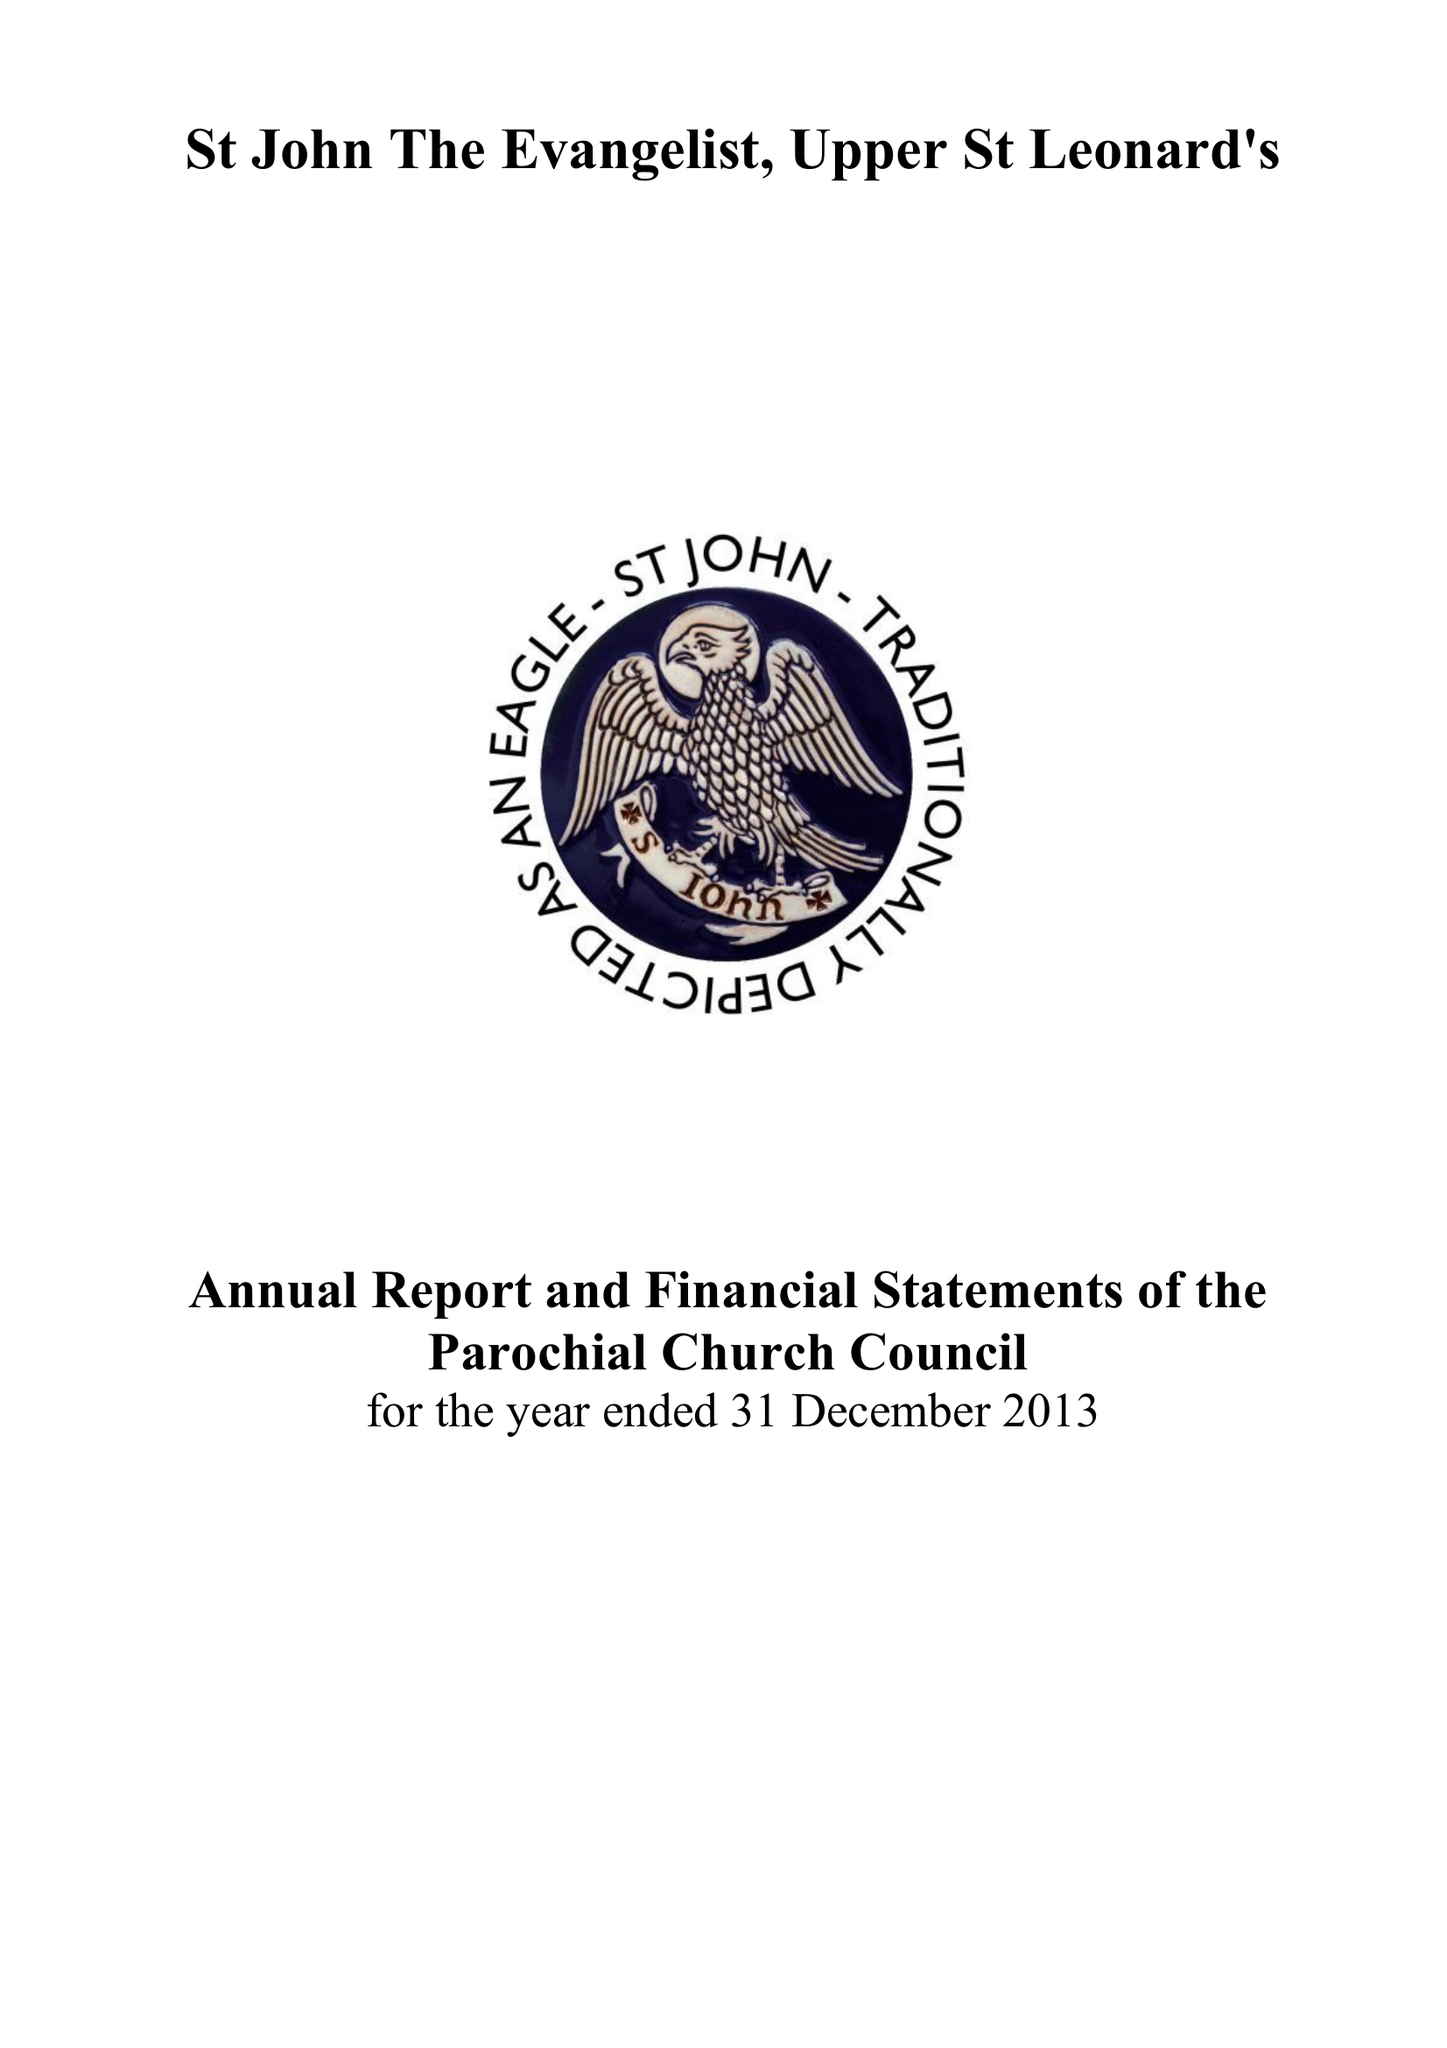What is the value for the spending_annually_in_british_pounds?
Answer the question using a single word or phrase. 130205.00 